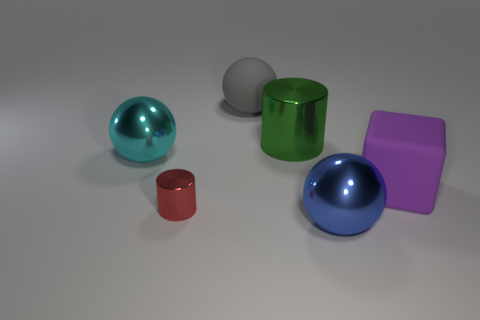Add 2 large gray objects. How many objects exist? 8 Subtract all red cylinders. How many cylinders are left? 1 Subtract all gray rubber spheres. How many spheres are left? 2 Subtract 1 cylinders. How many cylinders are left? 1 Subtract all cylinders. How many objects are left? 4 Subtract all red spheres. Subtract all blue cylinders. How many spheres are left? 3 Subtract all cyan cubes. How many purple spheres are left? 0 Subtract all cylinders. Subtract all tiny red things. How many objects are left? 3 Add 2 large cyan things. How many large cyan things are left? 3 Add 5 purple metallic cylinders. How many purple metallic cylinders exist? 5 